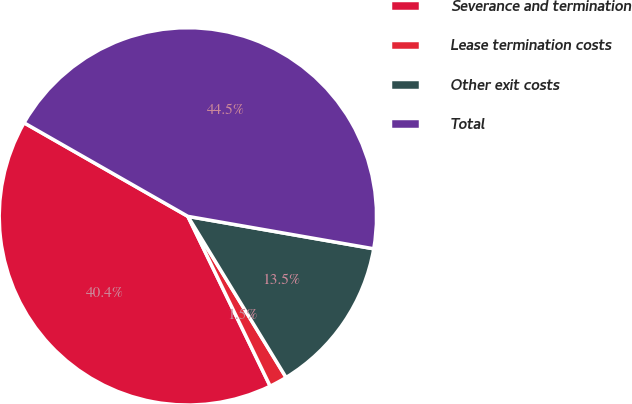Convert chart. <chart><loc_0><loc_0><loc_500><loc_500><pie_chart><fcel>Severance and termination<fcel>Lease termination costs<fcel>Other exit costs<fcel>Total<nl><fcel>40.44%<fcel>1.53%<fcel>13.54%<fcel>44.49%<nl></chart> 